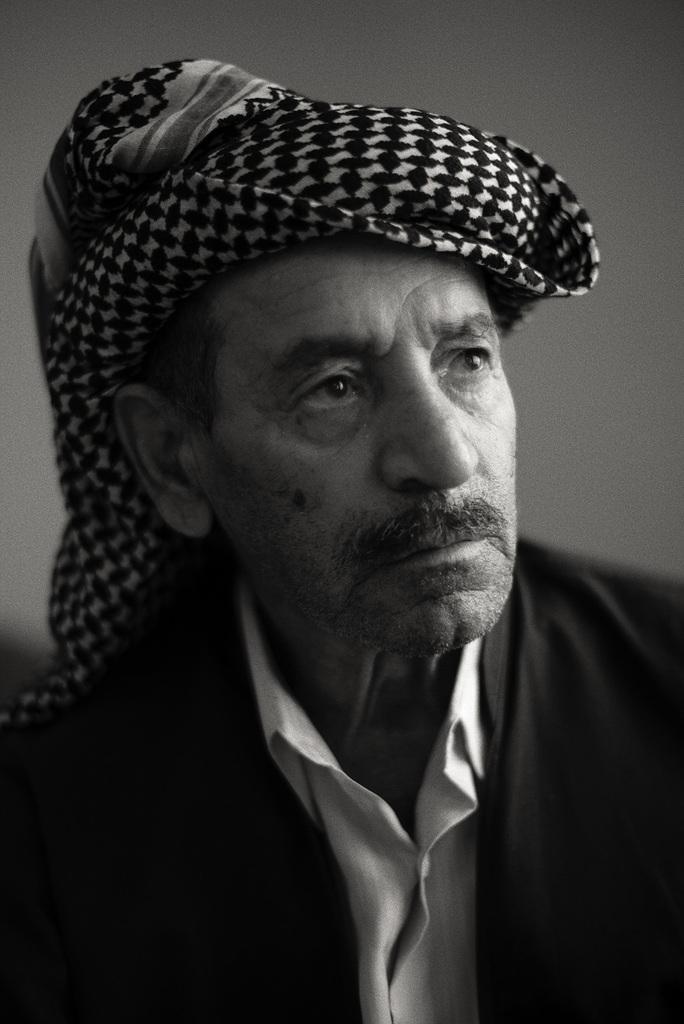In one or two sentences, can you explain what this image depicts? In this picture we can see a man, he wore a scarf and it is a black and white photography. 